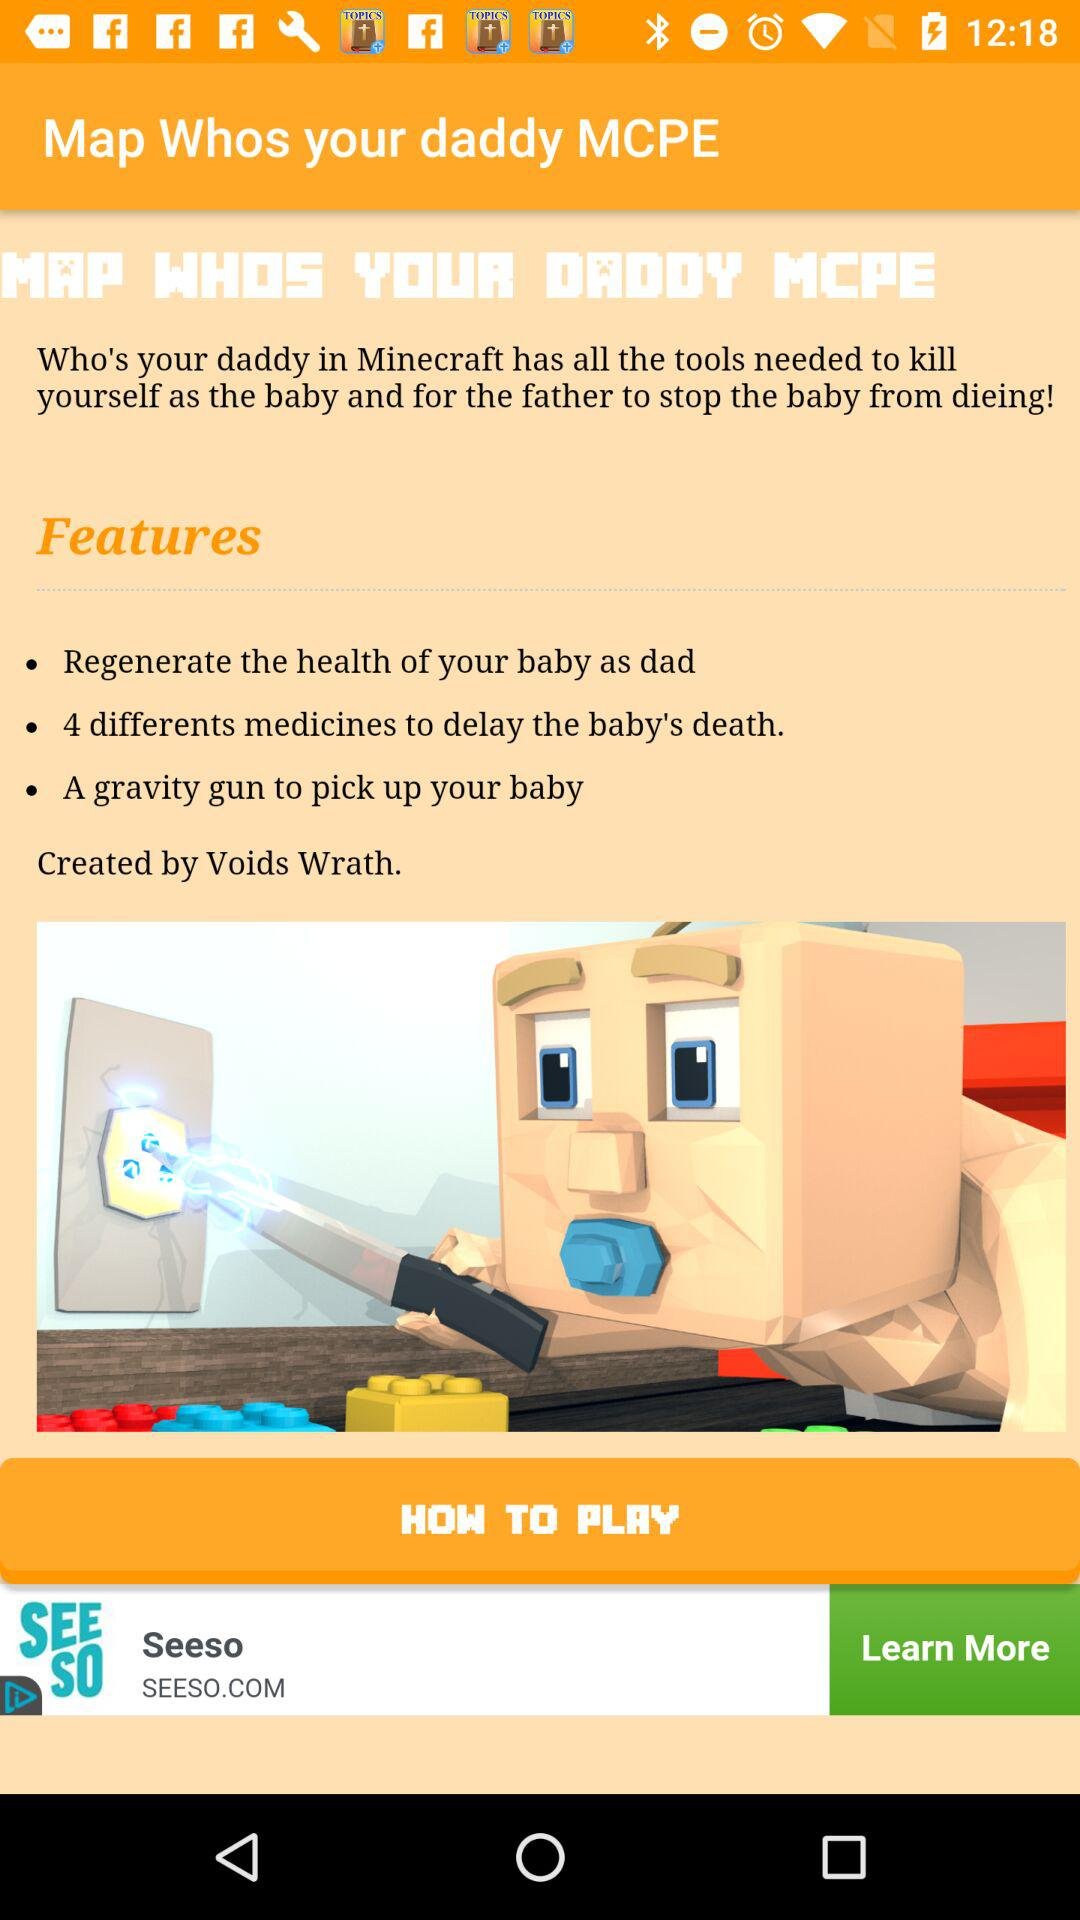Who is the creator? The creator is Voids Wrath. 